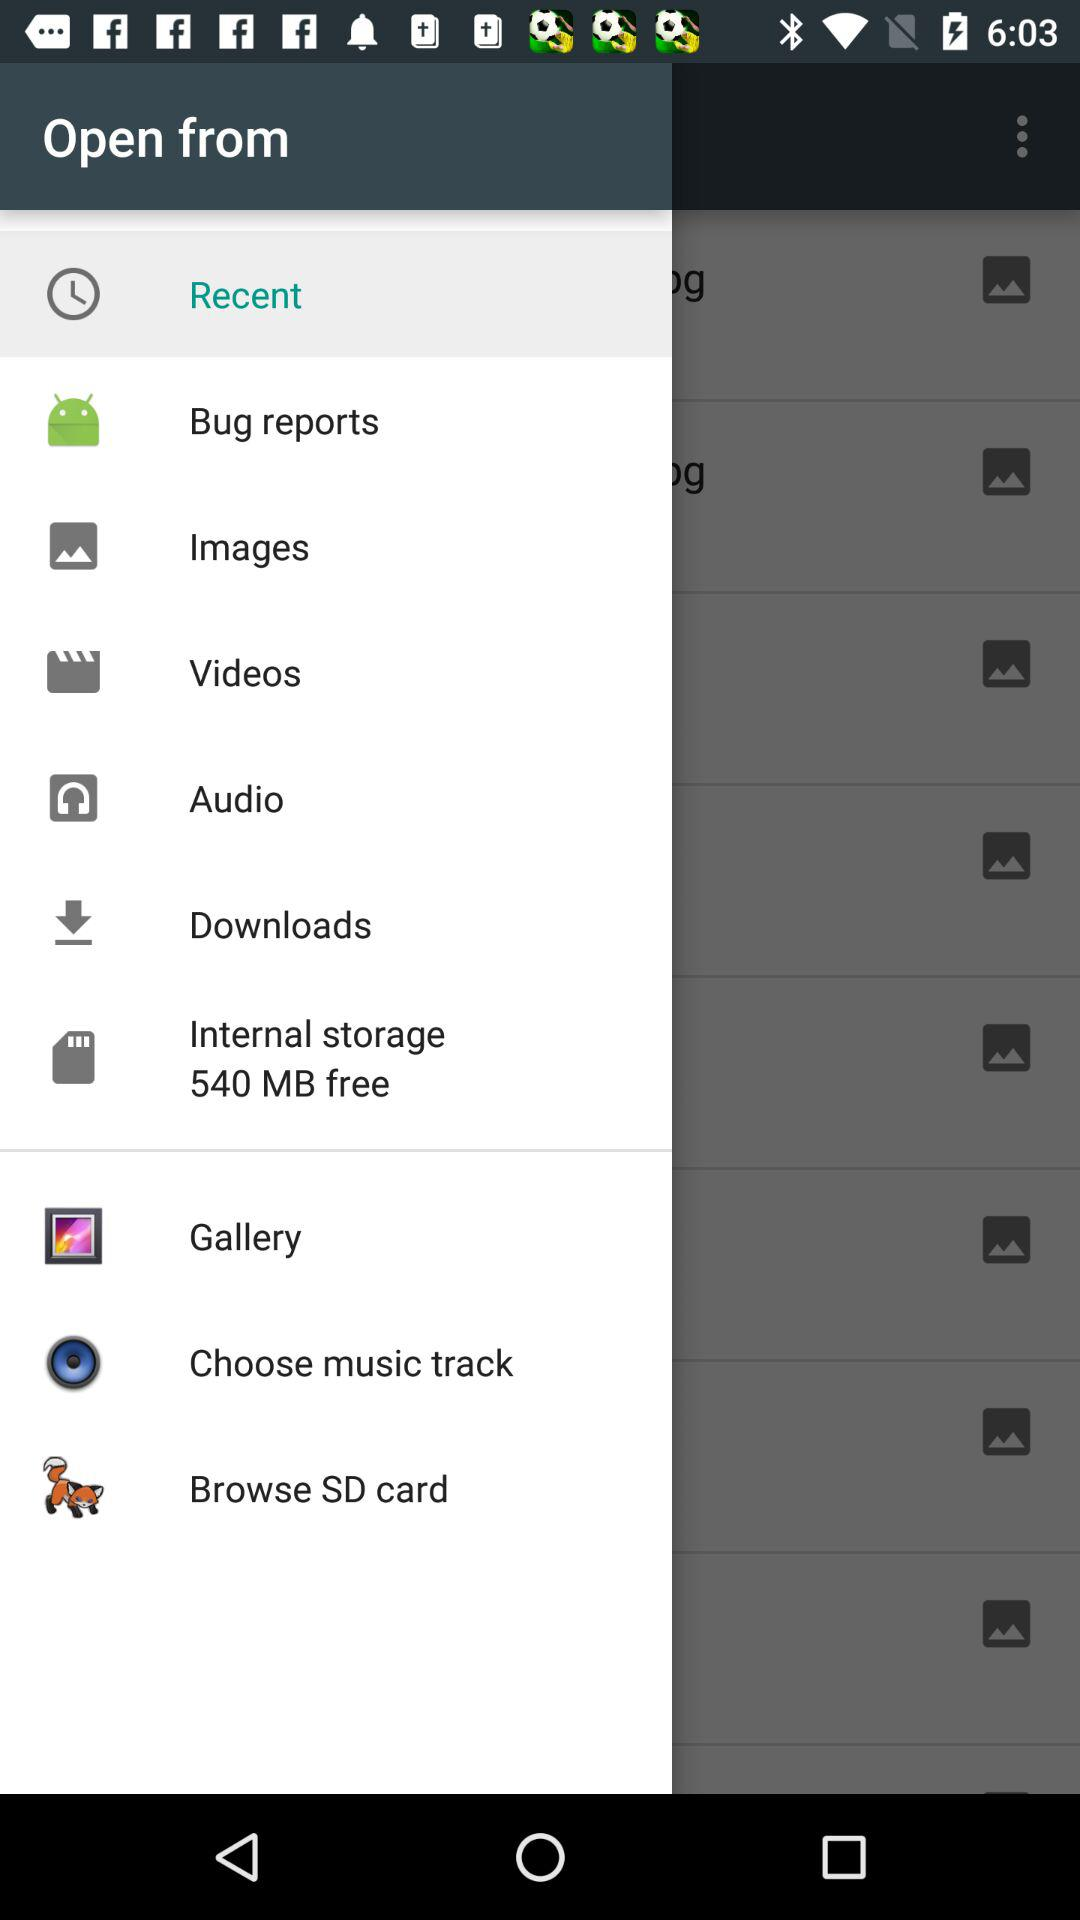Which option is selected? The selected option is "Recent". 